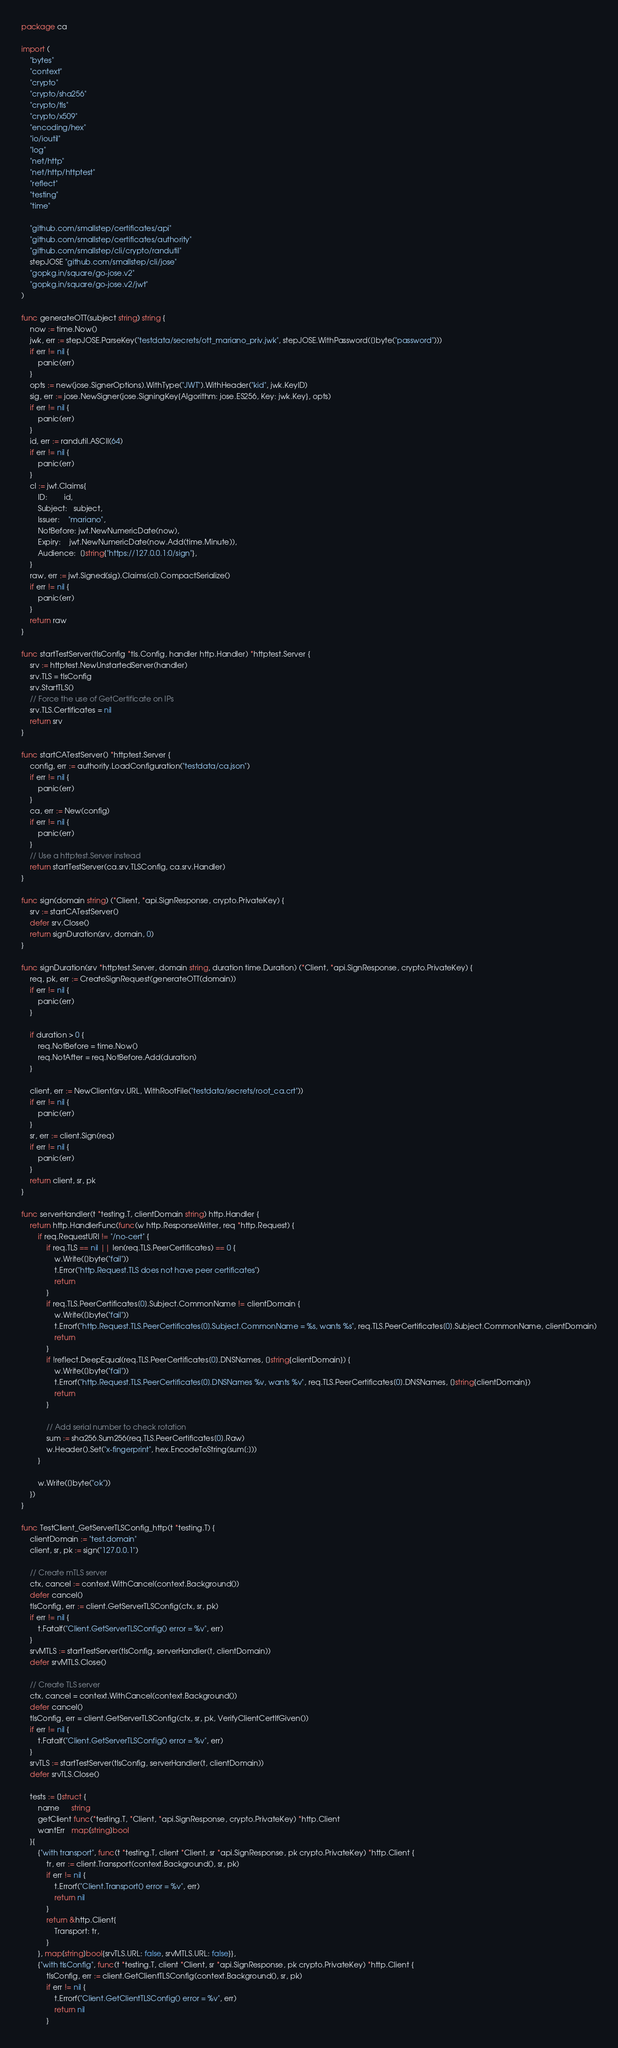<code> <loc_0><loc_0><loc_500><loc_500><_Go_>package ca

import (
	"bytes"
	"context"
	"crypto"
	"crypto/sha256"
	"crypto/tls"
	"crypto/x509"
	"encoding/hex"
	"io/ioutil"
	"log"
	"net/http"
	"net/http/httptest"
	"reflect"
	"testing"
	"time"

	"github.com/smallstep/certificates/api"
	"github.com/smallstep/certificates/authority"
	"github.com/smallstep/cli/crypto/randutil"
	stepJOSE "github.com/smallstep/cli/jose"
	"gopkg.in/square/go-jose.v2"
	"gopkg.in/square/go-jose.v2/jwt"
)

func generateOTT(subject string) string {
	now := time.Now()
	jwk, err := stepJOSE.ParseKey("testdata/secrets/ott_mariano_priv.jwk", stepJOSE.WithPassword([]byte("password")))
	if err != nil {
		panic(err)
	}
	opts := new(jose.SignerOptions).WithType("JWT").WithHeader("kid", jwk.KeyID)
	sig, err := jose.NewSigner(jose.SigningKey{Algorithm: jose.ES256, Key: jwk.Key}, opts)
	if err != nil {
		panic(err)
	}
	id, err := randutil.ASCII(64)
	if err != nil {
		panic(err)
	}
	cl := jwt.Claims{
		ID:        id,
		Subject:   subject,
		Issuer:    "mariano",
		NotBefore: jwt.NewNumericDate(now),
		Expiry:    jwt.NewNumericDate(now.Add(time.Minute)),
		Audience:  []string{"https://127.0.0.1:0/sign"},
	}
	raw, err := jwt.Signed(sig).Claims(cl).CompactSerialize()
	if err != nil {
		panic(err)
	}
	return raw
}

func startTestServer(tlsConfig *tls.Config, handler http.Handler) *httptest.Server {
	srv := httptest.NewUnstartedServer(handler)
	srv.TLS = tlsConfig
	srv.StartTLS()
	// Force the use of GetCertificate on IPs
	srv.TLS.Certificates = nil
	return srv
}

func startCATestServer() *httptest.Server {
	config, err := authority.LoadConfiguration("testdata/ca.json")
	if err != nil {
		panic(err)
	}
	ca, err := New(config)
	if err != nil {
		panic(err)
	}
	// Use a httptest.Server instead
	return startTestServer(ca.srv.TLSConfig, ca.srv.Handler)
}

func sign(domain string) (*Client, *api.SignResponse, crypto.PrivateKey) {
	srv := startCATestServer()
	defer srv.Close()
	return signDuration(srv, domain, 0)
}

func signDuration(srv *httptest.Server, domain string, duration time.Duration) (*Client, *api.SignResponse, crypto.PrivateKey) {
	req, pk, err := CreateSignRequest(generateOTT(domain))
	if err != nil {
		panic(err)
	}

	if duration > 0 {
		req.NotBefore = time.Now()
		req.NotAfter = req.NotBefore.Add(duration)
	}

	client, err := NewClient(srv.URL, WithRootFile("testdata/secrets/root_ca.crt"))
	if err != nil {
		panic(err)
	}
	sr, err := client.Sign(req)
	if err != nil {
		panic(err)
	}
	return client, sr, pk
}

func serverHandler(t *testing.T, clientDomain string) http.Handler {
	return http.HandlerFunc(func(w http.ResponseWriter, req *http.Request) {
		if req.RequestURI != "/no-cert" {
			if req.TLS == nil || len(req.TLS.PeerCertificates) == 0 {
				w.Write([]byte("fail"))
				t.Error("http.Request.TLS does not have peer certificates")
				return
			}
			if req.TLS.PeerCertificates[0].Subject.CommonName != clientDomain {
				w.Write([]byte("fail"))
				t.Errorf("http.Request.TLS.PeerCertificates[0].Subject.CommonName = %s, wants %s", req.TLS.PeerCertificates[0].Subject.CommonName, clientDomain)
				return
			}
			if !reflect.DeepEqual(req.TLS.PeerCertificates[0].DNSNames, []string{clientDomain}) {
				w.Write([]byte("fail"))
				t.Errorf("http.Request.TLS.PeerCertificates[0].DNSNames %v, wants %v", req.TLS.PeerCertificates[0].DNSNames, []string{clientDomain})
				return
			}

			// Add serial number to check rotation
			sum := sha256.Sum256(req.TLS.PeerCertificates[0].Raw)
			w.Header().Set("x-fingerprint", hex.EncodeToString(sum[:]))
		}

		w.Write([]byte("ok"))
	})
}

func TestClient_GetServerTLSConfig_http(t *testing.T) {
	clientDomain := "test.domain"
	client, sr, pk := sign("127.0.0.1")

	// Create mTLS server
	ctx, cancel := context.WithCancel(context.Background())
	defer cancel()
	tlsConfig, err := client.GetServerTLSConfig(ctx, sr, pk)
	if err != nil {
		t.Fatalf("Client.GetServerTLSConfig() error = %v", err)
	}
	srvMTLS := startTestServer(tlsConfig, serverHandler(t, clientDomain))
	defer srvMTLS.Close()

	// Create TLS server
	ctx, cancel = context.WithCancel(context.Background())
	defer cancel()
	tlsConfig, err = client.GetServerTLSConfig(ctx, sr, pk, VerifyClientCertIfGiven())
	if err != nil {
		t.Fatalf("Client.GetServerTLSConfig() error = %v", err)
	}
	srvTLS := startTestServer(tlsConfig, serverHandler(t, clientDomain))
	defer srvTLS.Close()

	tests := []struct {
		name      string
		getClient func(*testing.T, *Client, *api.SignResponse, crypto.PrivateKey) *http.Client
		wantErr   map[string]bool
	}{
		{"with transport", func(t *testing.T, client *Client, sr *api.SignResponse, pk crypto.PrivateKey) *http.Client {
			tr, err := client.Transport(context.Background(), sr, pk)
			if err != nil {
				t.Errorf("Client.Transport() error = %v", err)
				return nil
			}
			return &http.Client{
				Transport: tr,
			}
		}, map[string]bool{srvTLS.URL: false, srvMTLS.URL: false}},
		{"with tlsConfig", func(t *testing.T, client *Client, sr *api.SignResponse, pk crypto.PrivateKey) *http.Client {
			tlsConfig, err := client.GetClientTLSConfig(context.Background(), sr, pk)
			if err != nil {
				t.Errorf("Client.GetClientTLSConfig() error = %v", err)
				return nil
			}</code> 